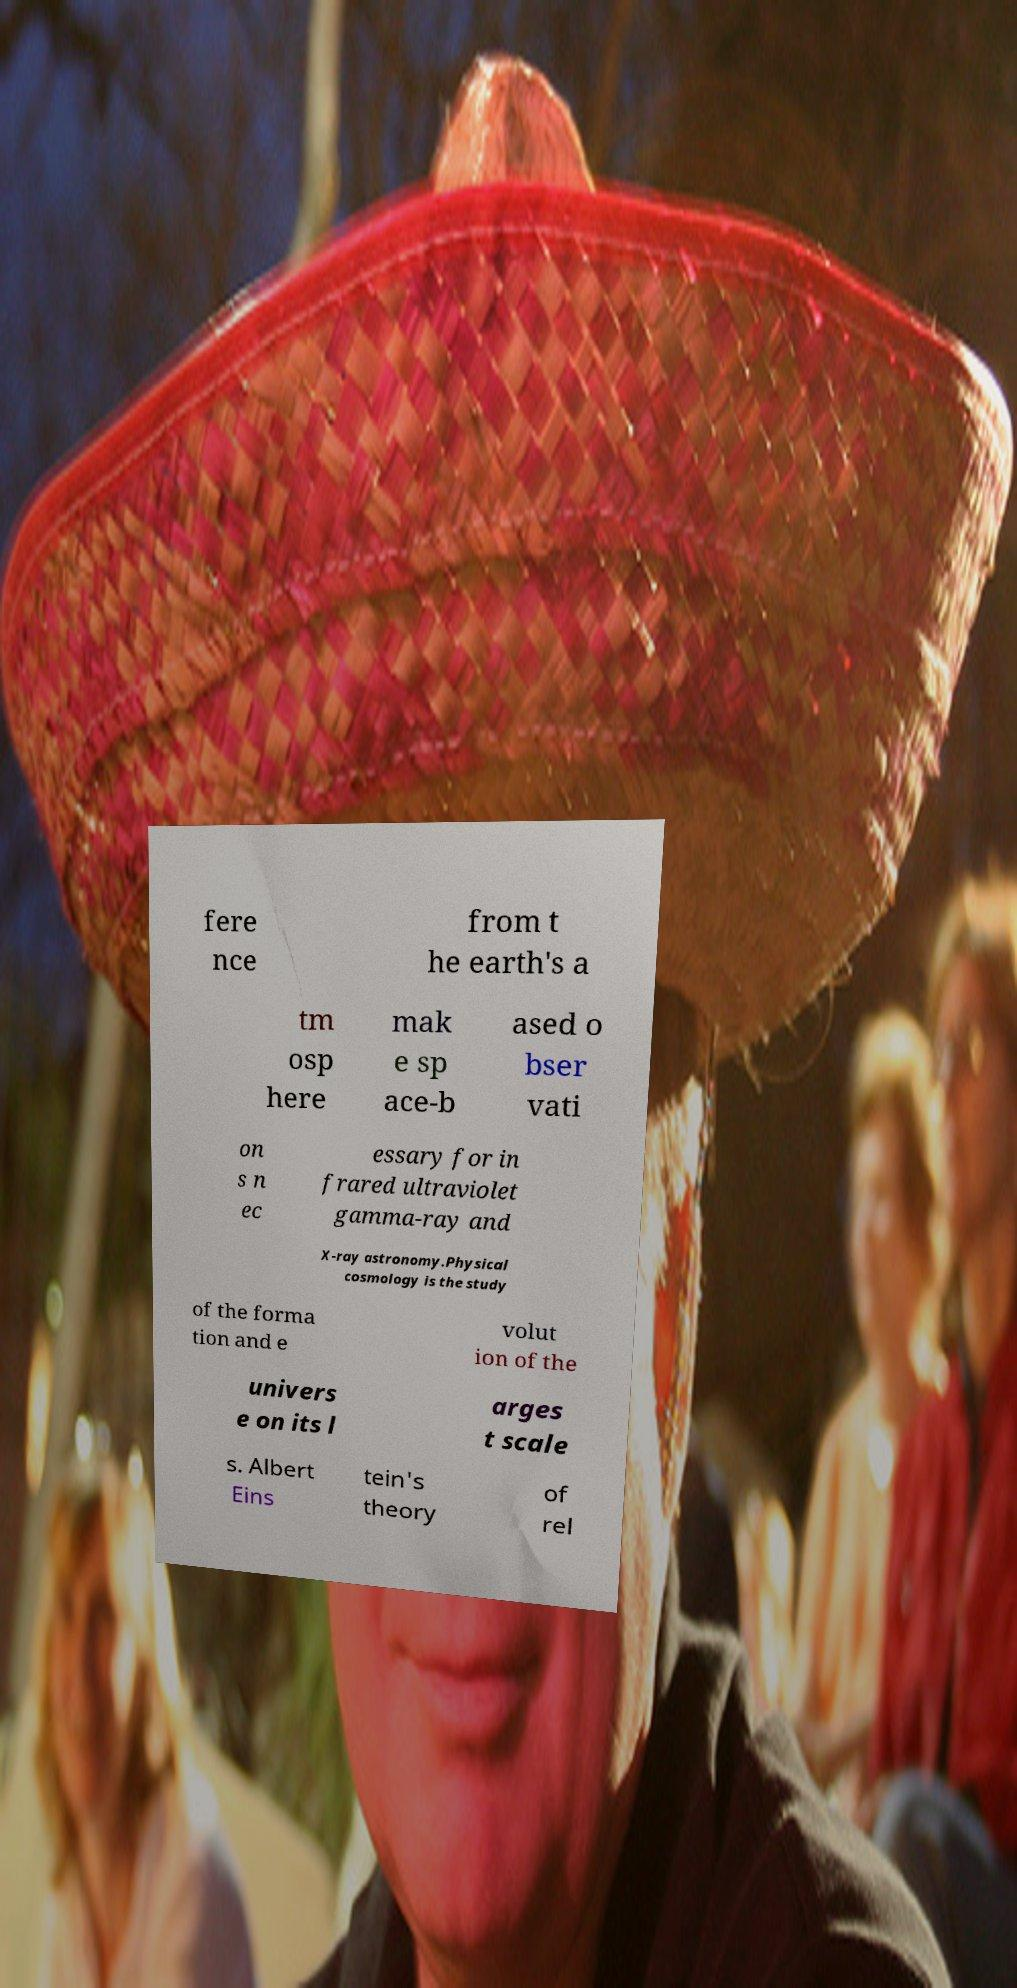Could you assist in decoding the text presented in this image and type it out clearly? fere nce from t he earth's a tm osp here mak e sp ace-b ased o bser vati on s n ec essary for in frared ultraviolet gamma-ray and X-ray astronomy.Physical cosmology is the study of the forma tion and e volut ion of the univers e on its l arges t scale s. Albert Eins tein's theory of rel 